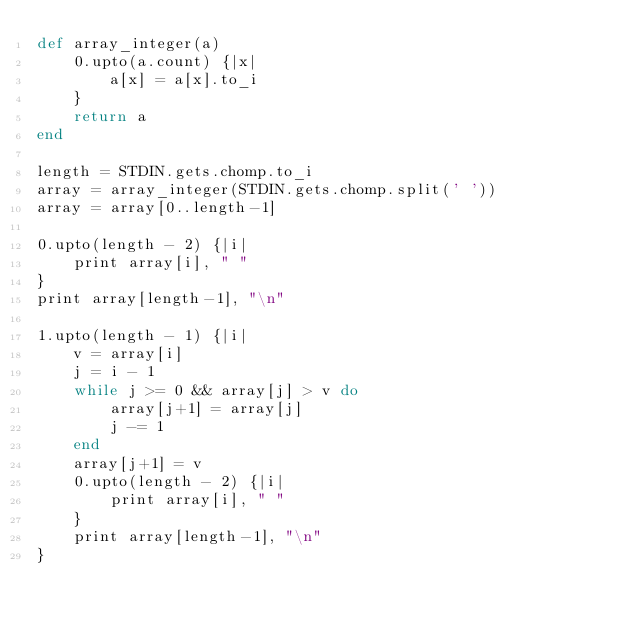Convert code to text. <code><loc_0><loc_0><loc_500><loc_500><_Ruby_>def array_integer(a)
	0.upto(a.count) {|x|
		a[x] = a[x].to_i
	}
	return a
end

length = STDIN.gets.chomp.to_i
array = array_integer(STDIN.gets.chomp.split(' '))
array = array[0..length-1]

0.upto(length - 2) {|i|
	print array[i], " "
}
print array[length-1], "\n"
	
1.upto(length - 1) {|i|
	v = array[i]
	j = i - 1
	while j >= 0 && array[j] > v do
		array[j+1] = array[j]
		j -= 1
	end
	array[j+1] = v
	0.upto(length - 2) {|i|
		print array[i], " "
	}
	print array[length-1], "\n"
}
</code> 